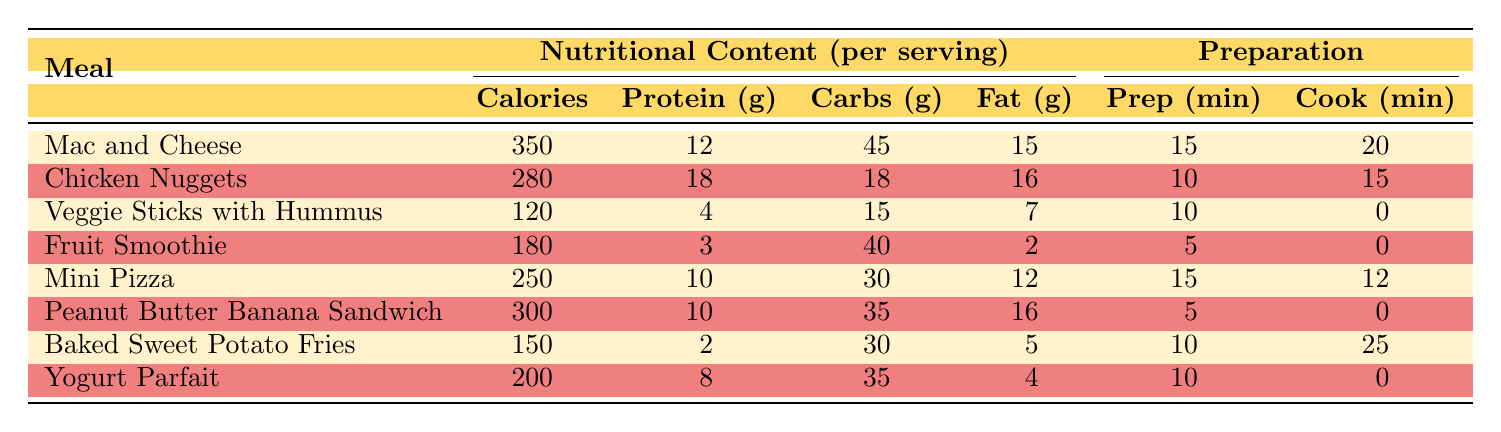What is the highest calorie meal among the listed options? By inspecting the table, I can see that "Mac and Cheese" has the highest calorie count at 350 calories compared to the other meals.
Answer: 350 calories How many grams of protein does the "Fruit Smoothie" contain? The table directly lists that the "Fruit Smoothie" has 3 grams of protein.
Answer: 3 grams Which meal has the least amount of fat, and what is its fat content? Looking at the fat column, I find that "Fruit Smoothie" has the least amount of fat at 2 grams.
Answer: 2 grams What is the average prep time for the snacks in the table? The snacks are "Veggie Sticks with Hummus" and "Peanut Butter Banana Sandwich." Their prep times are 10 and 5 minutes, respectively. The average is (10 + 5) / 2 = 7.5 minutes.
Answer: 7.5 minutes Is the "Peanut Butter Banana Sandwich" higher in calories than the "Baked Sweet Potato Fries"? "Peanut Butter Banana Sandwich" has 300 calories while "Baked Sweet Potato Fries" has 150 calories, so yes, it is higher in calories.
Answer: Yes Which main dish has the highest protein content, and how much does it contain? By comparing the protein content of the main dishes, "Chicken Nuggets" has the highest protein at 18 grams.
Answer: 18 grams What is the total amount of carbs across all the meals in the table? I will sum up the carbs for each meal: 45 (Mac and Cheese) + 18 (Chicken Nuggets) + 15 (Veggie Sticks with Hummus) + 40 (Fruit Smoothie) + 30 (Mini Pizza) + 35 (Peanut Butter Banana Sandwich) + 30 (Baked Sweet Potato Fries) + 35 (Yogurt Parfait) = 303 grams of carbs in total.
Answer: 303 grams Does any meal have 0 grams of sugar, and if so, which one? Checking the sugar column, I can see that "Chicken Nuggets" has 0 grams of sugar.
Answer: Yes, Chicken Nuggets What is the meal with the shortest cook time, and what is its cook time? By scanning the cook time column, I find that "Fruit Smoothie" has a cook time of 0 minutes, which is the shortest time.
Answer: 0 minutes 